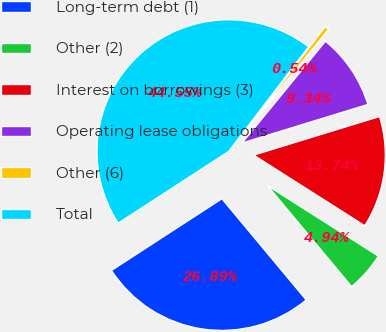Convert chart. <chart><loc_0><loc_0><loc_500><loc_500><pie_chart><fcel>Long-term debt (1)<fcel>Other (2)<fcel>Interest on borrowings (3)<fcel>Operating lease obligations<fcel>Other (6)<fcel>Total<nl><fcel>26.88%<fcel>4.94%<fcel>13.74%<fcel>9.34%<fcel>0.54%<fcel>44.54%<nl></chart> 